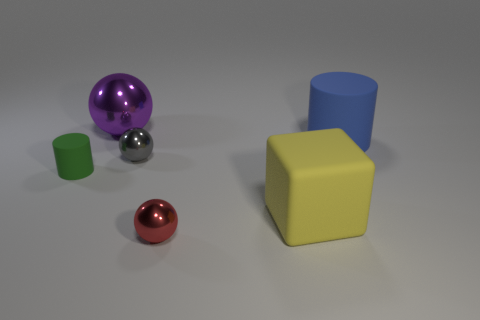Add 3 tiny shiny things. How many objects exist? 9 Subtract all cylinders. How many objects are left? 4 Subtract 0 blue blocks. How many objects are left? 6 Subtract all green rubber things. Subtract all tiny metallic things. How many objects are left? 3 Add 3 small red metallic spheres. How many small red metallic spheres are left? 4 Add 4 small purple objects. How many small purple objects exist? 4 